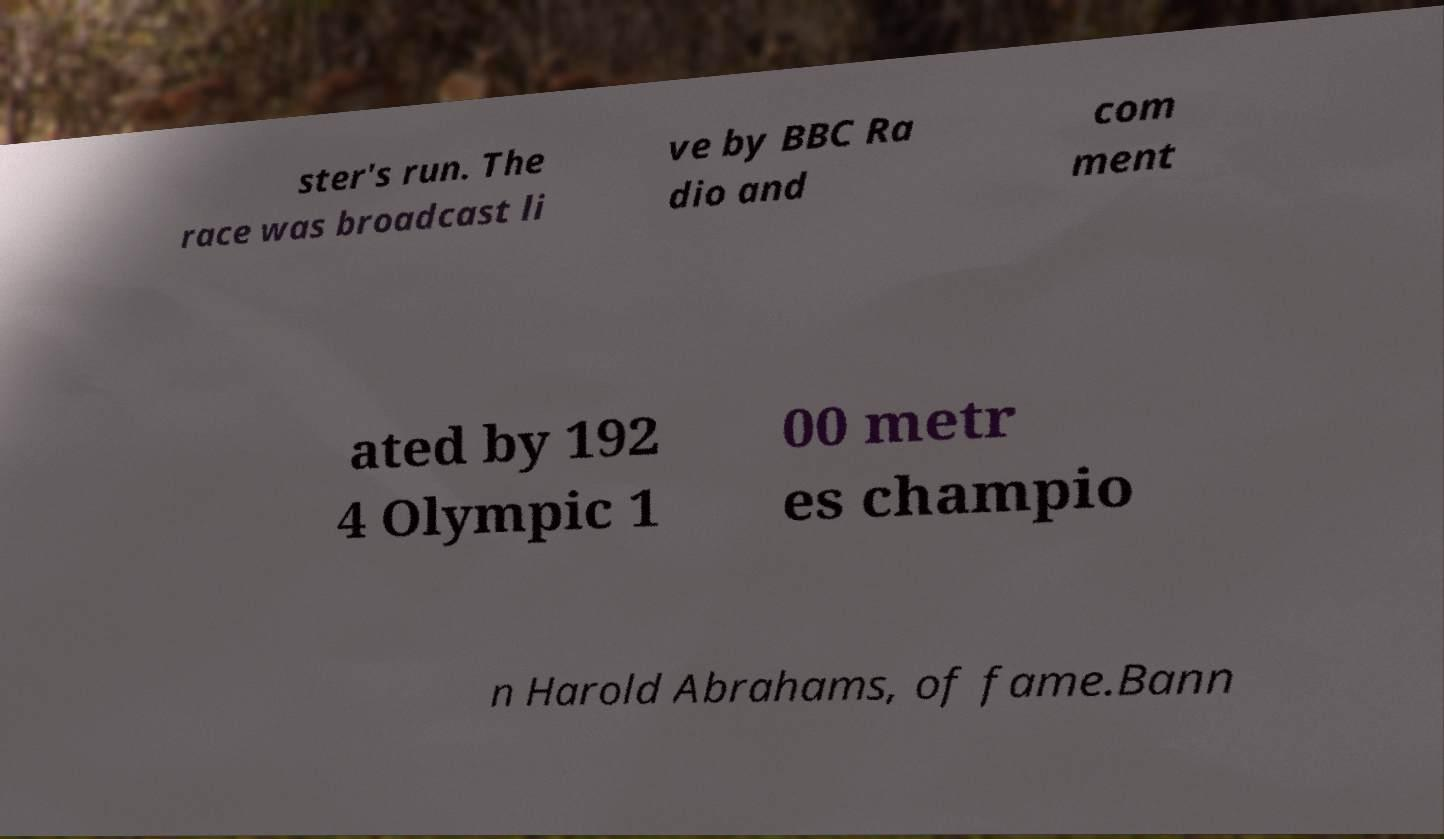There's text embedded in this image that I need extracted. Can you transcribe it verbatim? ster's run. The race was broadcast li ve by BBC Ra dio and com ment ated by 192 4 Olympic 1 00 metr es champio n Harold Abrahams, of fame.Bann 